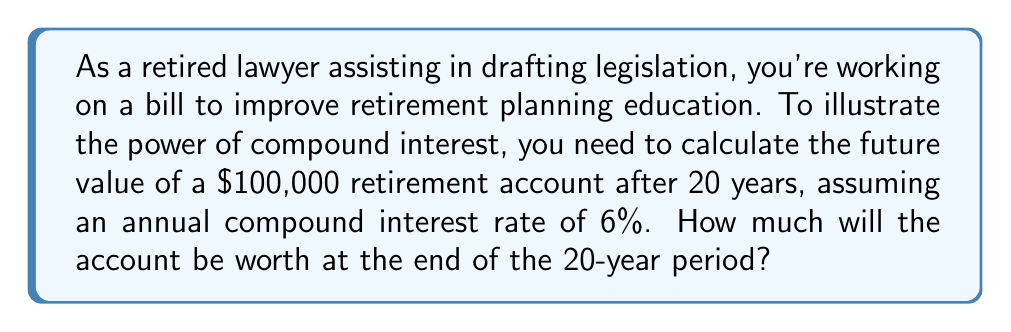Provide a solution to this math problem. To solve this problem, we'll use the compound interest formula:

$$A = P(1 + r)^t$$

Where:
$A$ = Final amount
$P$ = Principal (initial investment)
$r$ = Annual interest rate (as a decimal)
$t$ = Time in years

Given:
$P = 100,000$
$r = 0.06$ (6% expressed as a decimal)
$t = 20$ years

Let's substitute these values into the formula:

$$A = 100,000(1 + 0.06)^{20}$$

Now, let's solve step-by-step:

1) First, calculate $(1 + 0.06)^{20}$:
   $$(1.06)^{20} \approx 3.20714$$ 
   
2) Multiply this result by the principal:
   $$100,000 \times 3.20714 = 320,714$$

Therefore, after 20 years, the $100,000 retirement account will grow to approximately $320,714.

This example demonstrates the power of compound interest over time, which is crucial for effective retirement planning.
Answer: $320,714 